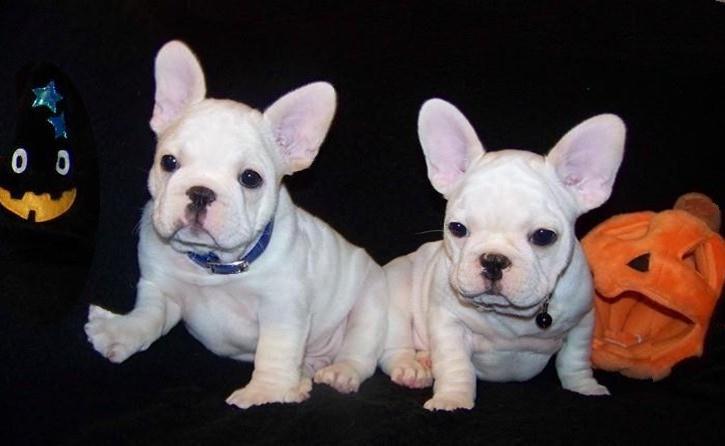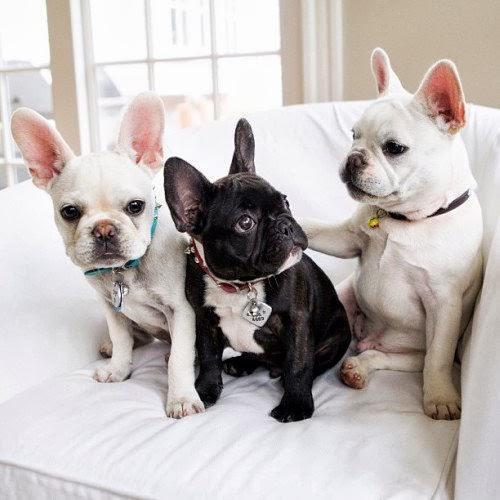The first image is the image on the left, the second image is the image on the right. Considering the images on both sides, is "An image shows at least three dogs, including a black one, all posed together on a fabric covered seat." valid? Answer yes or no. Yes. The first image is the image on the left, the second image is the image on the right. For the images displayed, is the sentence "There is no more than three dogs in the right image." factually correct? Answer yes or no. Yes. 